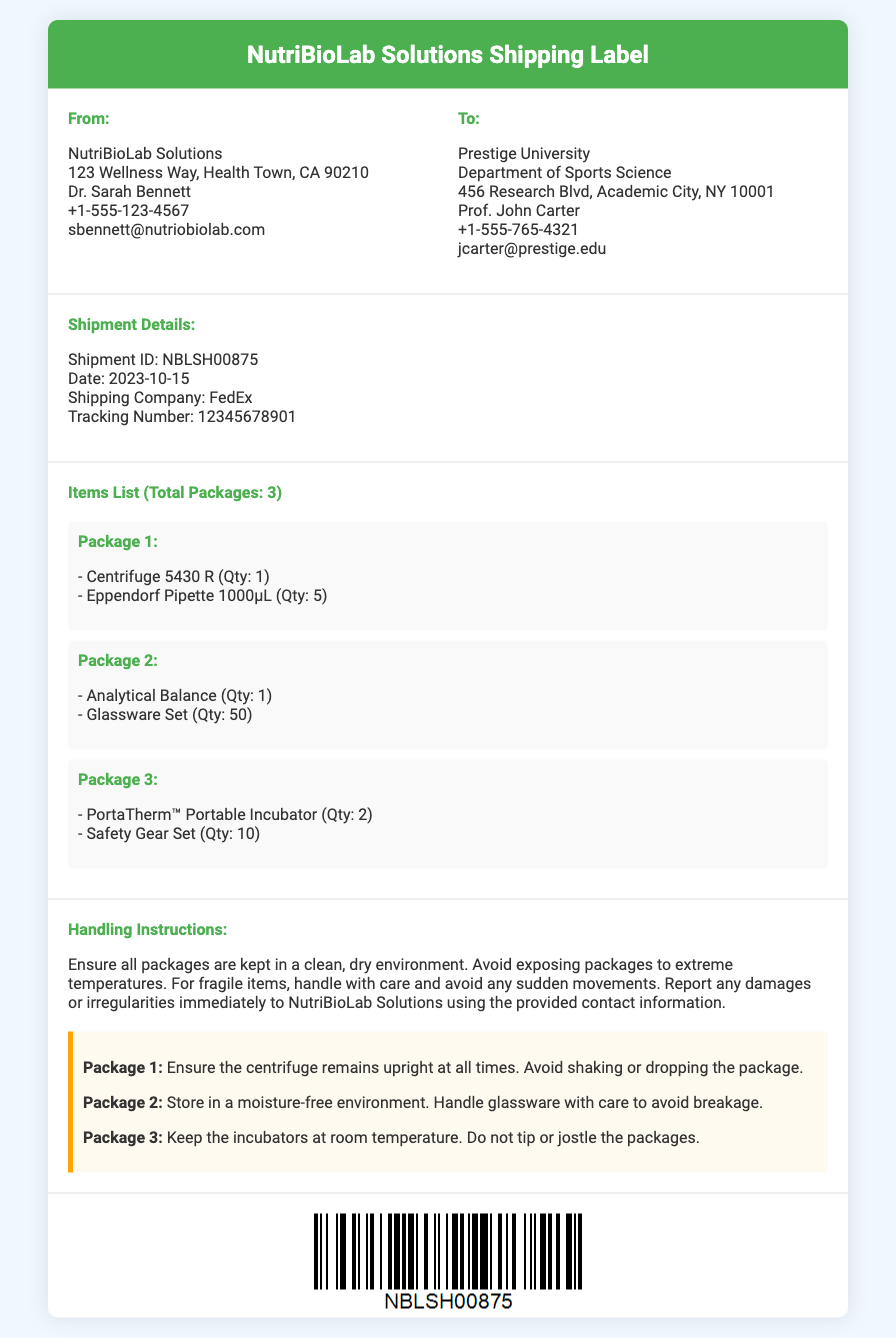What is the sender's address? The sender's address is provided under the "From" section, listing NutriBioLab Solutions and their contact details.
Answer: 123 Wellness Way, Health Town, CA 90210 Who is the recipient of this shipment? The recipient is specified under the "To" section, providing the name and department of the contact.
Answer: Prof. John Carter What is the shipment ID? The shipment ID is found in the "Shipment Details" section and is a unique identifier for this shipment.
Answer: NBLSH00875 How many packages are listed in the items list? The total number of packages is explicitly stated in the "Items List" section.
Answer: 3 What handling instruction is given for Package 2? Specific handling instructions for Package 2 are outlined under the "Handling Instructions" section.
Answer: Store in a moisture-free environment What is the quantity of Eppendorf Pipette included in the shipment? The quantity of Eppendorf Pipette is specified under Package 1 in the items list.
Answer: 5 What is the tracking number provided for this shipment? The tracking number can be found in the "Shipment Details" section and is used to track the shipment.
Answer: 12345678901 How should the centrifuge be handled according to the instructions? The handling instructions for the centrifuge are clearly stated, emphasizing care.
Answer: Ensure the centrifuge remains upright at all times 